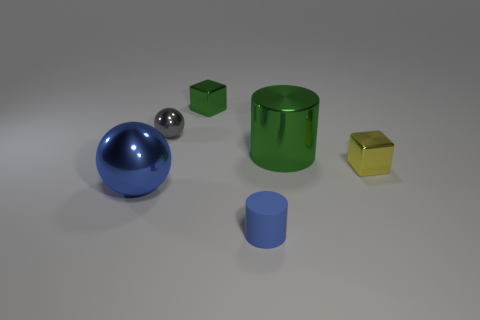Add 3 small cyan cylinders. How many objects exist? 9 Subtract all yellow blocks. How many blocks are left? 1 Subtract 1 cylinders. How many cylinders are left? 1 Add 5 large yellow spheres. How many large yellow spheres exist? 5 Subtract 0 green spheres. How many objects are left? 6 Subtract all cubes. How many objects are left? 4 Subtract all red balls. Subtract all red cubes. How many balls are left? 2 Subtract all red cylinders. How many purple blocks are left? 0 Subtract all small red rubber spheres. Subtract all blue rubber cylinders. How many objects are left? 5 Add 5 big green objects. How many big green objects are left? 6 